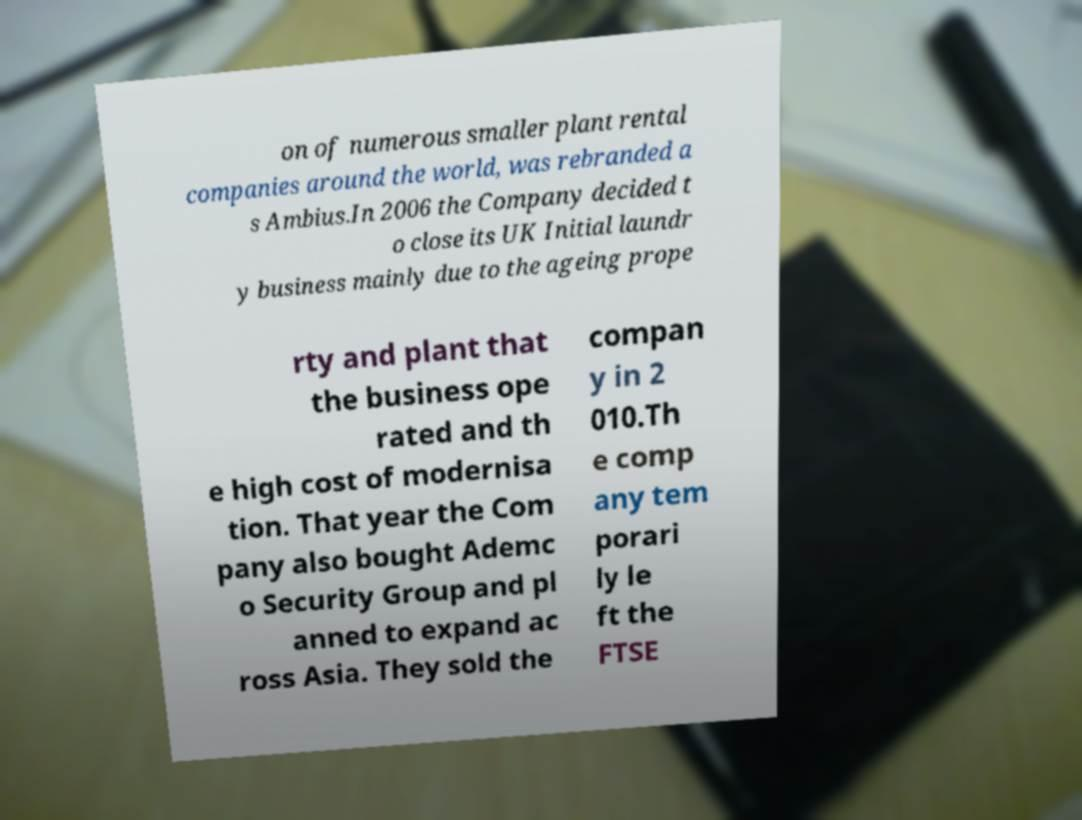What messages or text are displayed in this image? I need them in a readable, typed format. on of numerous smaller plant rental companies around the world, was rebranded a s Ambius.In 2006 the Company decided t o close its UK Initial laundr y business mainly due to the ageing prope rty and plant that the business ope rated and th e high cost of modernisa tion. That year the Com pany also bought Ademc o Security Group and pl anned to expand ac ross Asia. They sold the compan y in 2 010.Th e comp any tem porari ly le ft the FTSE 